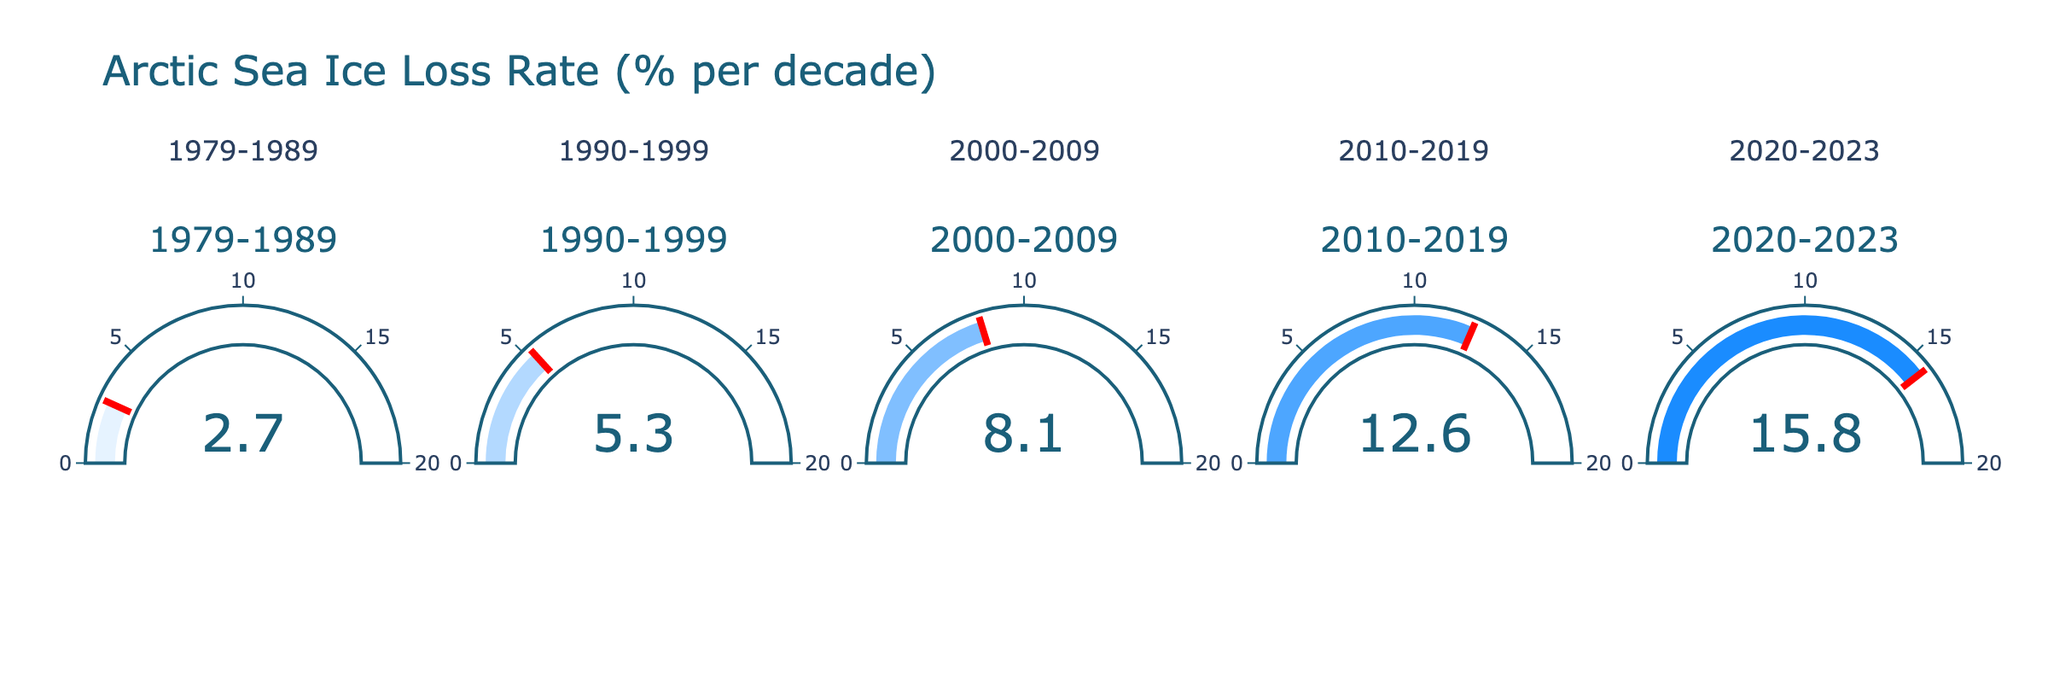What's the title of the figure? The title is written at the top center of the figure, which reads "Arctic Sea Ice Loss Rate (% per decade)".
Answer: Arctic Sea Ice Loss Rate (% per decade) How many gauge charts are displayed in the figure? The figure consists of one row with five columns, each containing a gauge chart, indicating a total of five gauge charts.
Answer: Five Which decade has the highest rate of Arctic sea ice loss? By looking at each gauge chart, the decade 2020-2023 has the highest value displayed, which is 15.8%.
Answer: 2020-2023 Compare the Arctic sea ice loss rate between the decades 1979-1989 and 2010-2019. The chart for 1979-1989 shows a value of 2.7%, while the chart for 2010-2019 shows a value of 12.6%. To compare, 12.6% is significantly higher than 2.7%.
Answer: 12.6% is higher than 2.7% What is the average rate of Arctic sea ice loss over the five periods shown? Add the percentages for each decade (2.7 + 5.3 + 8.1 + 12.6 + 15.8) and then divide by the number of periods, which is 5. The total is 44.5, and the average is 44.5/5 = 8.9%.
Answer: 8.9% Which decade saw more than double the rate of Arctic sea ice loss compared to the 1990-1999 period? The 1990-1999 period had a rate of 5.3%. Double this is 10.6%. Both 2010-2019 (12.6%) and 2020-2023 (15.8%) saw more than double the rate of 5.3%.
Answer: 2010-2019 and 2020-2023 Between which consecutive decades did the Arctic sea ice loss rate increase the most? To find this, calculate the differences: 1990-1999 - 1979-1989 = 5.3 - 2.7 = 2.6, 2000-2009 - 1990-1999 = 8.1 - 5.3 = 2.8, 2010-2019 - 2000-2009 = 12.6 - 8.1 = 4.5, and 2020-2023 - 2010-2019 = 15.8 - 12.6 = 3.2. The greatest increase is from 2000-2009 to 2010-2019, which is 4.5%.
Answer: 2000-2009 to 2010-2019 What visual feature emphasizes the current Arctic sea ice loss rate in each gauge? The red threshold line in each gauge visually emphasizes the current rate by marking its position.
Answer: Red threshold line How does the color of the gauge bar change across the decades? The color of the gauge bars transitions from a lighter blue in the decade 1979-1989 to a darker blue in the decade 2020-2023, indicating an increase in the rate.
Answer: From light blue to dark blue 